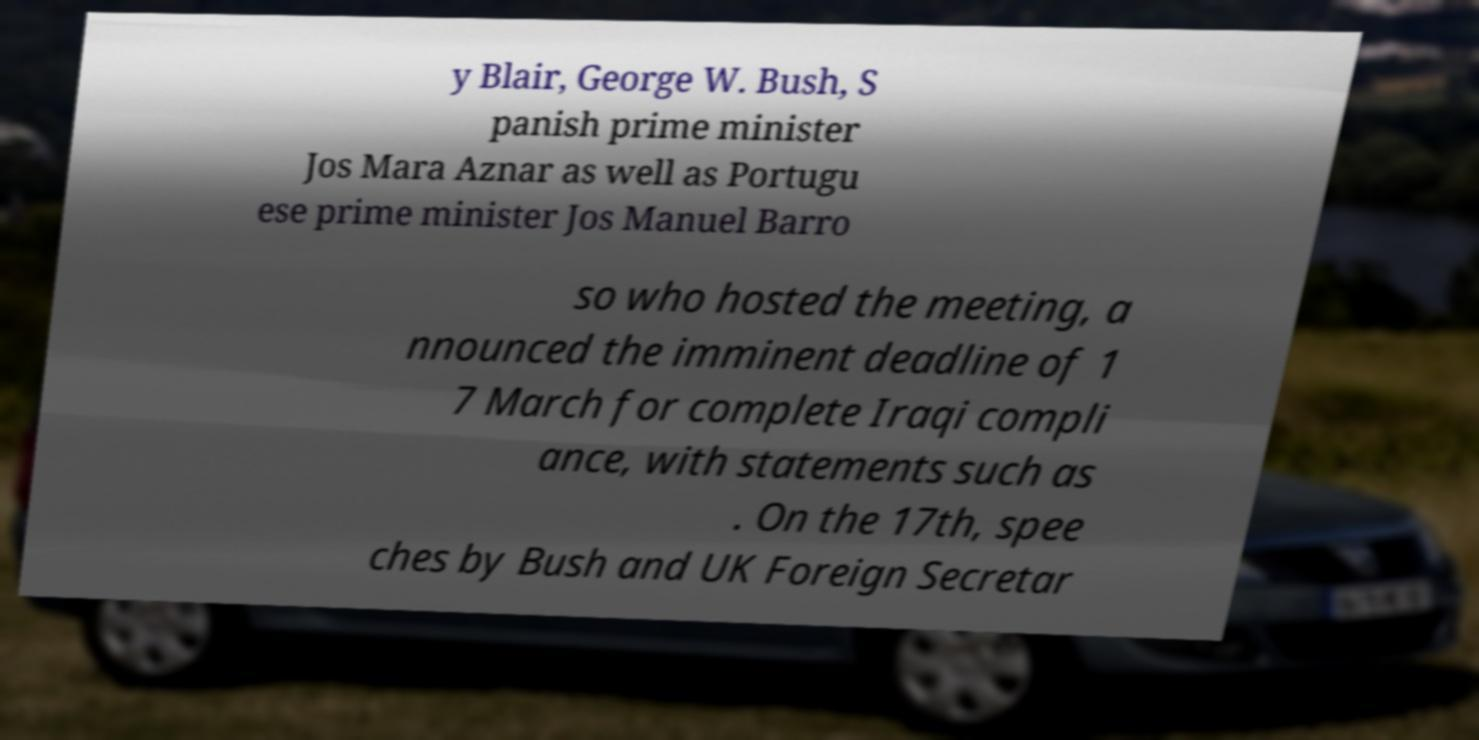There's text embedded in this image that I need extracted. Can you transcribe it verbatim? y Blair, George W. Bush, S panish prime minister Jos Mara Aznar as well as Portugu ese prime minister Jos Manuel Barro so who hosted the meeting, a nnounced the imminent deadline of 1 7 March for complete Iraqi compli ance, with statements such as . On the 17th, spee ches by Bush and UK Foreign Secretar 